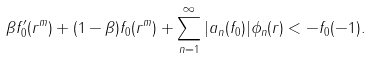<formula> <loc_0><loc_0><loc_500><loc_500>\beta f ^ { \prime } _ { 0 } ( r ^ { m } ) + ( 1 - \beta ) f _ { 0 } ( r ^ { m } ) + \sum _ { n = 1 } ^ { \infty } | a _ { n } ( f _ { 0 } ) | \phi _ { n } ( r ) < - f _ { 0 } ( - 1 ) .</formula> 